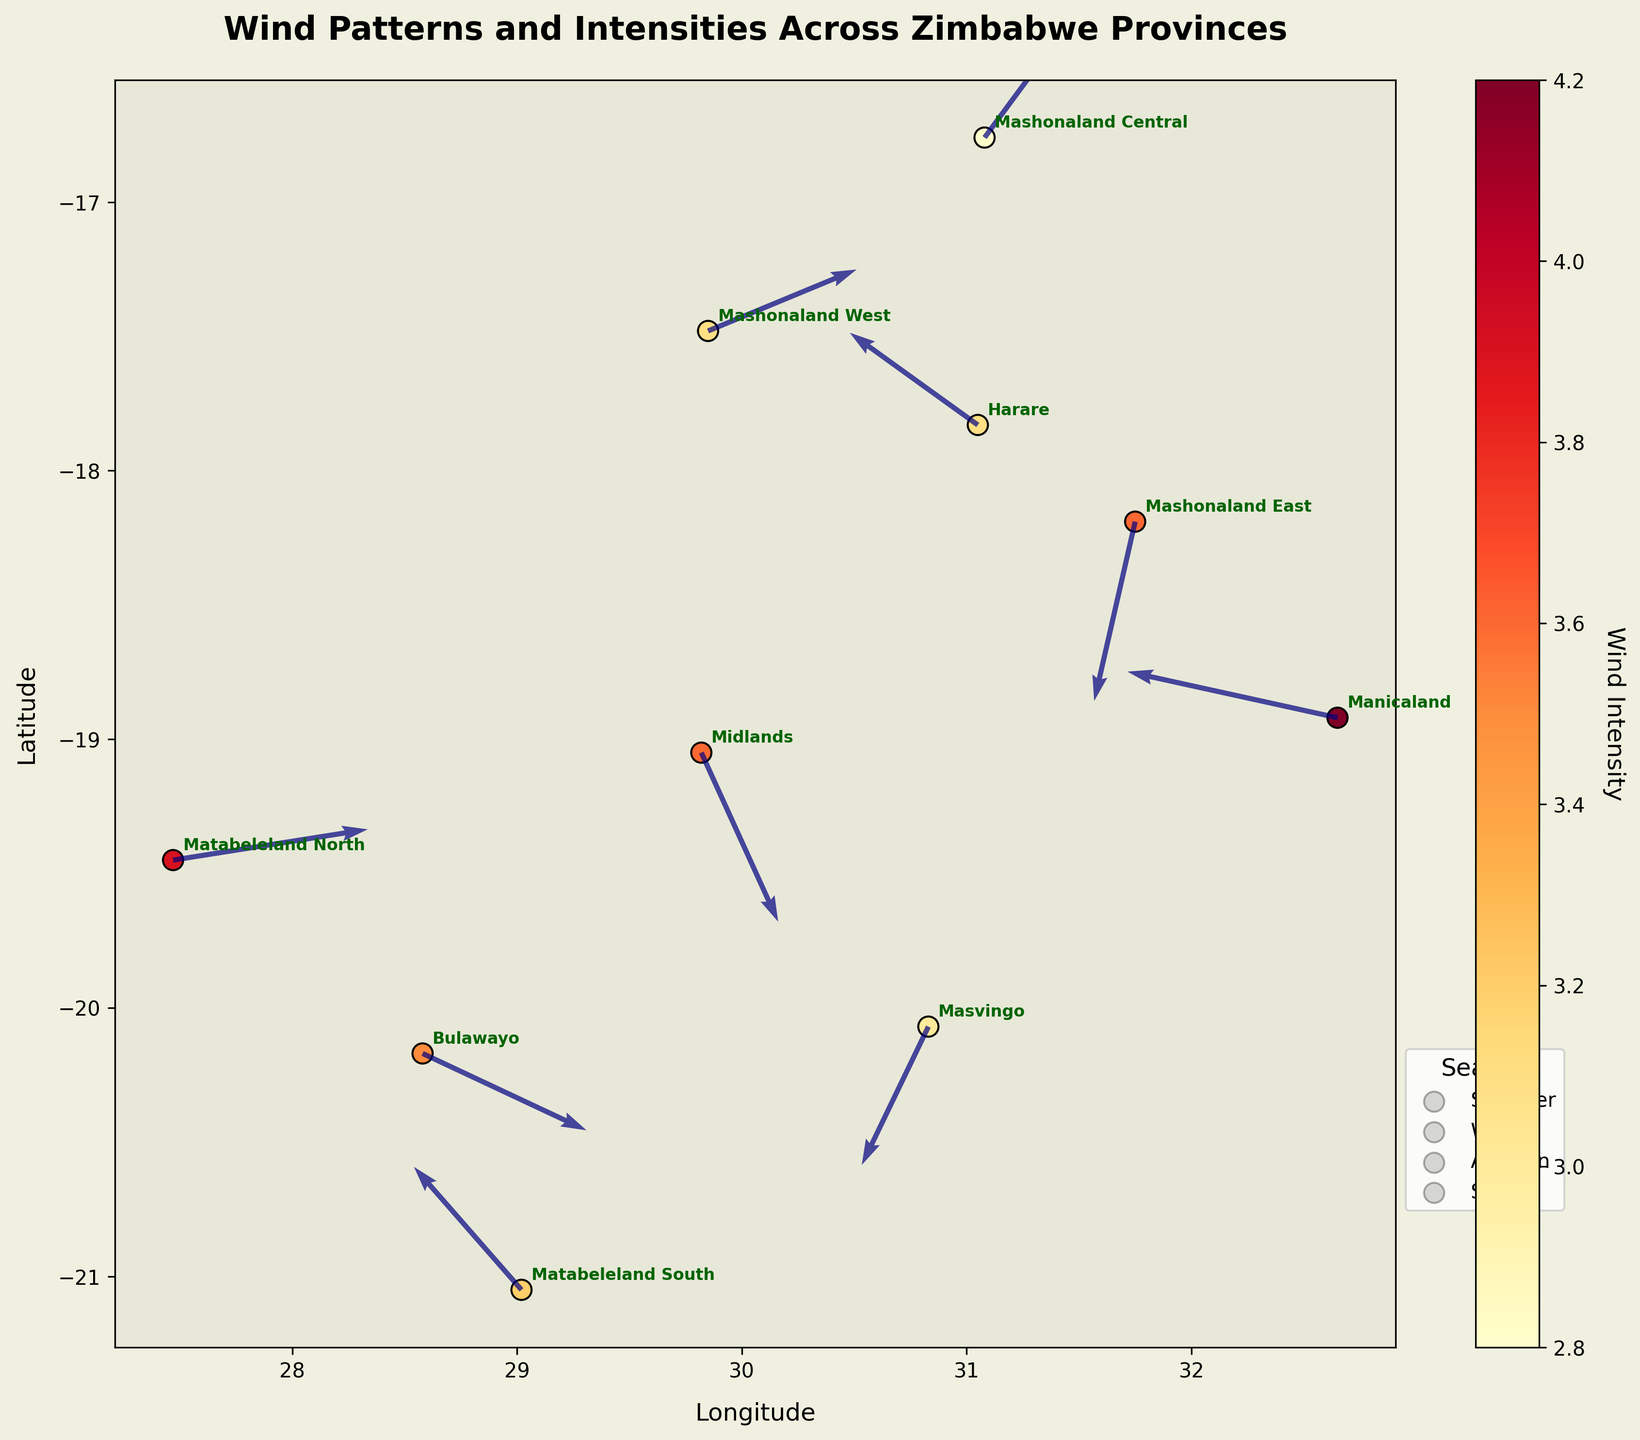What is the title of the quiver plot? The title is usually the text at the top of the plot that summarizes the figure. In this case, it reads "Wind Patterns and Intensities Across Zimbabwe Provinces".
Answer: Wind Patterns and Intensities Across Zimbabwe Provinces How many provinces are shown on the plot? Count the number of unique province names annotated on the plot. There are 10 unique province names: Harare, Bulawayo, Manicaland, Mashonaland Central, Mashonaland East, Mashonaland West, Masvingo, Matabeleland North, Matabeleland South, and Midlands.
Answer: 10 Which province has the highest wind intensity during summer? In summer, compare the intensity values of Harare, Bulawayo, and Manicaland. Harare's intensity is 3.1, Bulawayo's is 3.5, and Manicaland's is 4.2. The highest is 4.2 in Manicaland.
Answer: Manicaland Which direction is the wind blowing in Bulawayo during summer, based on the U and V components? The U component represents the horizontal (west-to-east) direction, and the V component represents the vertical (south-to-north) direction. In Bulawayo, U = 3.2 (eastwards) and V = -1.5 (southwards), indicating the wind is blowing southeast.
Answer: Southeast Compare the wind intensities in Mashonaland East and Midlands during winter and spring, respectively. Which has a higher intensity? Mashonaland East has an intensity of 3.6 in winter, and Midlands has an intensity of 3.6 in spring. Both are equal at 3.6.
Answer: Equal Which province experiences a northward wind direction in autumn? The V component should be positive for a northward direction. In Autumn, Matabeleland North has V = 0.6, indicating a northward wind. Masvingo has V = -2.7, indicating a southward wind.
Answer: Matabeleland North What is the average longitude (X coordinate) of all the provinces? Sum the longitudes of all provinces and divide by their number: (31.05 + 28.58 + 32.65 + 31.08 + 31.75 + 29.85 + 30.83 + 27.47 + 29.02 + 29.82) / 10 = 30.31.
Answer: 30.31 Which province has the most southward wind direction in spring? In spring, we compare the V components for Matabeleland South (V = 2.4) and Midlands (V = -3.3). The most southward direction is indicated by the lowest V value, so it is Midlands.
Answer: Midlands Among the provinces with wind blowing westward (negative U values), which has the highest wind intensity? Check which provinces have negative U values and compare their intensities. Harare (3.1), Manicaland (4.2), Mashonaland East (3.6), Masvingo (3.0), Matabeleland South (3.2). Manicaland has the highest intensity of 4.2.
Answer: Manicaland In which season does Mashonaland West experience wind, and what is the direction of the wind? For Mashonaland West, check the season and the U, V components. It’s winter, U=2.9 (eastwards), and V=1.2 (northwards), indicating the wind is blowing northeast.
Answer: Winter, Northeast 